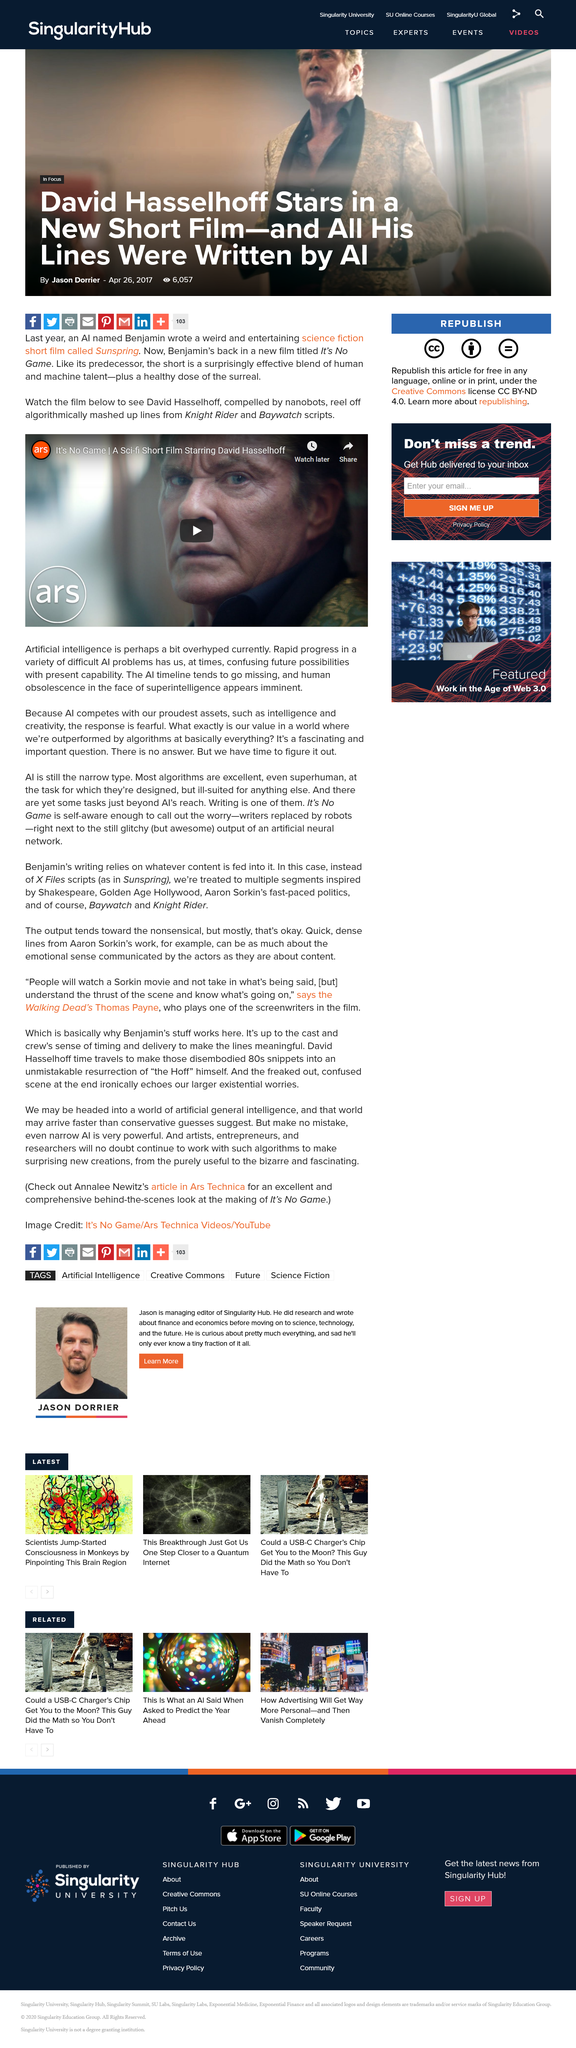Specify some key components in this picture. David Hasselhoff stars in the short film, It's No Game. The short film, "It's No Game," includes lines from scripts from the television series "Knight Rider" and "Baywatch. The short film called Sunspring was written by an AI named Benjamin. 